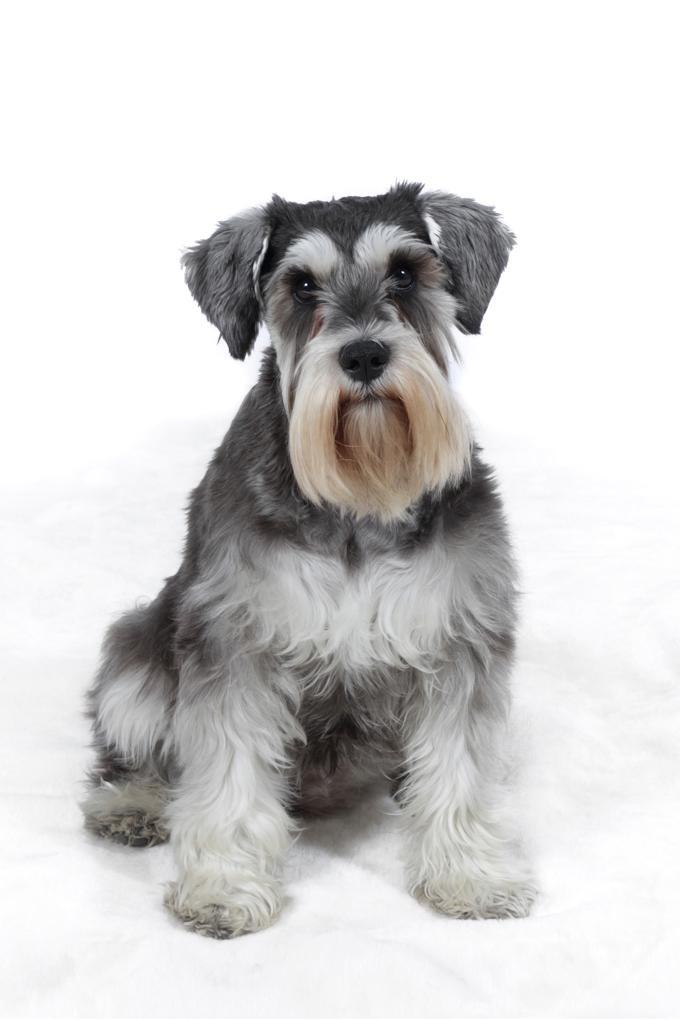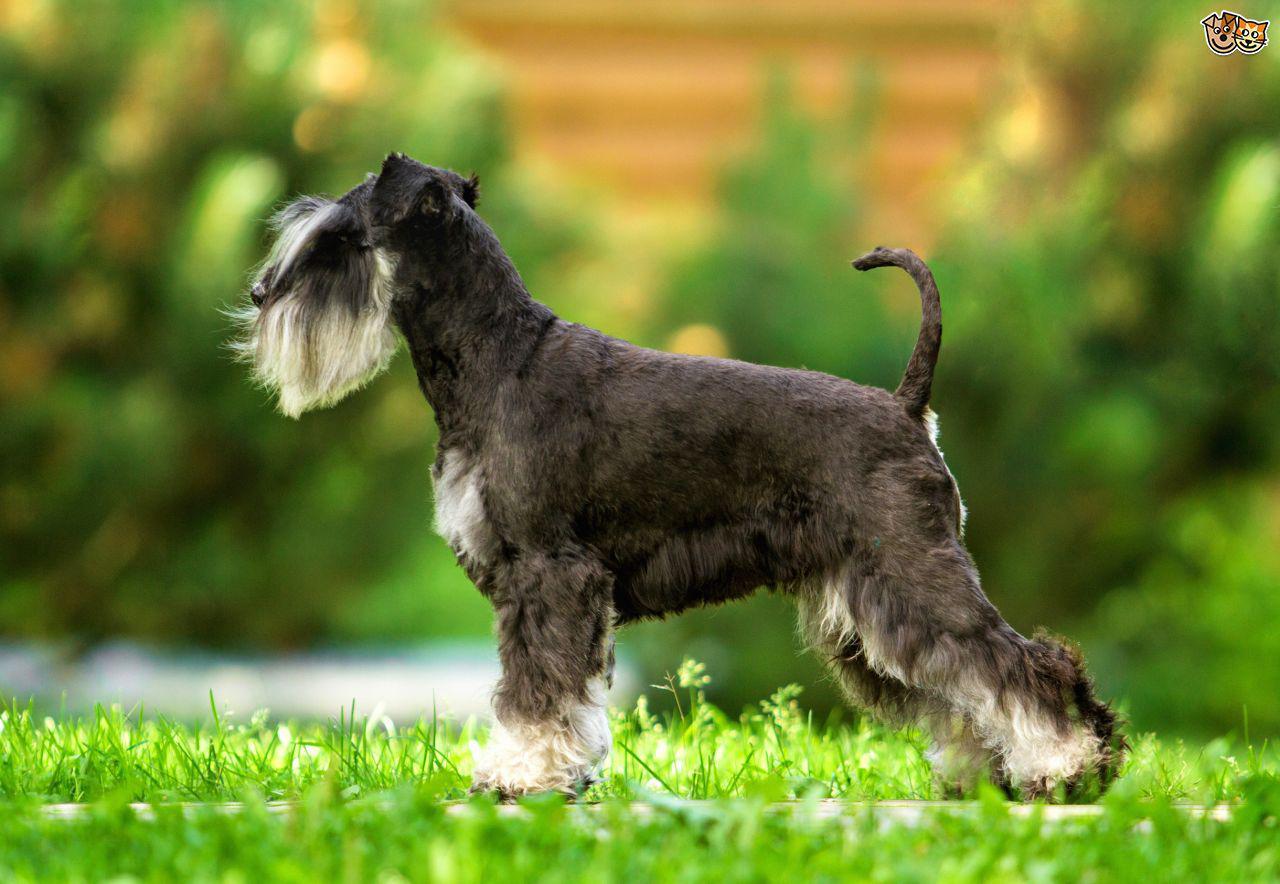The first image is the image on the left, the second image is the image on the right. Given the left and right images, does the statement "One image shows two schnauzers on the grass." hold true? Answer yes or no. No. The first image is the image on the left, the second image is the image on the right. Examine the images to the left and right. Is the description "One dog has pointy ears and two dogs have ears turned down." accurate? Answer yes or no. No. 